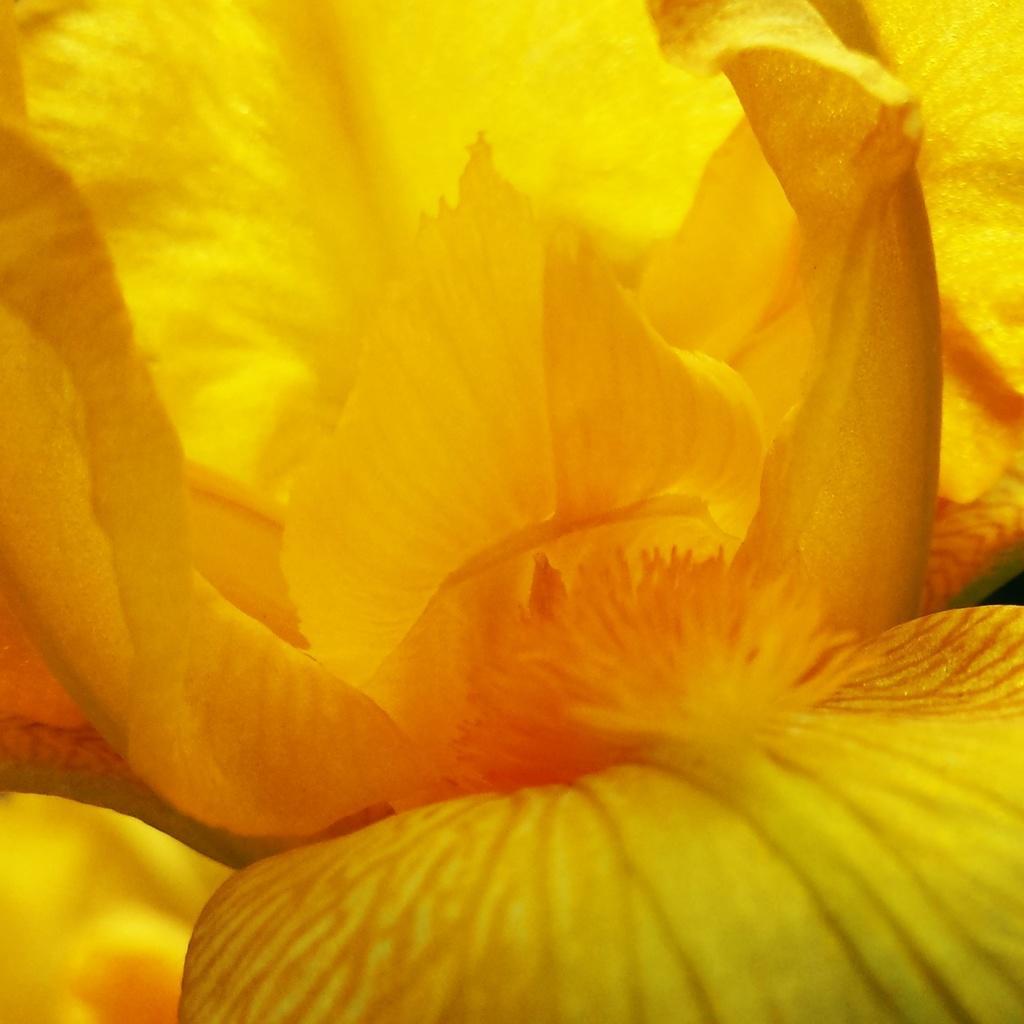Describe this image in one or two sentences. In this image we can see there is a flower which is zoomed and the flower is yellow color. 